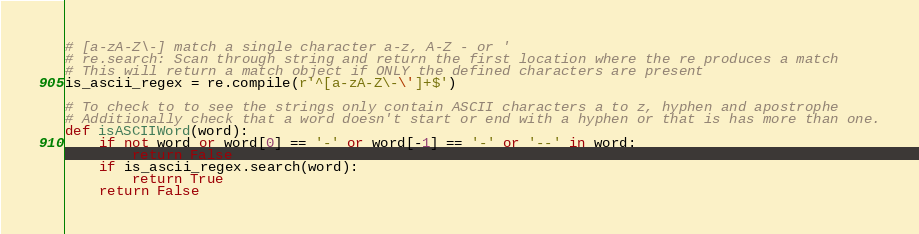<code> <loc_0><loc_0><loc_500><loc_500><_Python_># [a-zA-Z\-] match a single character a-z, A-Z - or '
# re.search: Scan through string and return the first location where the re produces a match
# This will return a match object if ONLY the defined characters are present
is_ascii_regex = re.compile(r'^[a-zA-Z\-\']+$')

# To check to to see the strings only contain ASCII characters a to z, hyphen and apostrophe
# Additionally check that a word doesn't start or end with a hyphen or that is has more than one.
def isASCIIWord(word):
    if not word or word[0] == '-' or word[-1] == '-' or '--' in word:
        return False
    if is_ascii_regex.search(word):
        return True
    return False
</code> 